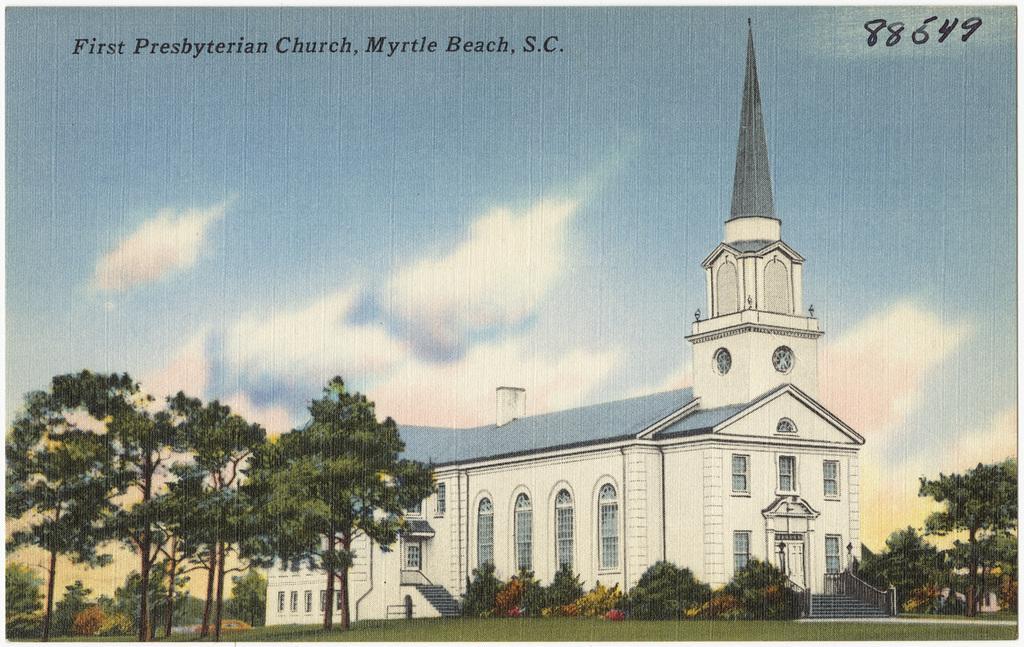How would you summarize this image in a sentence or two? In this image I can see trees, grass, plants, building, windows, staircase, text and the sky. This image looks like an edited photo. 